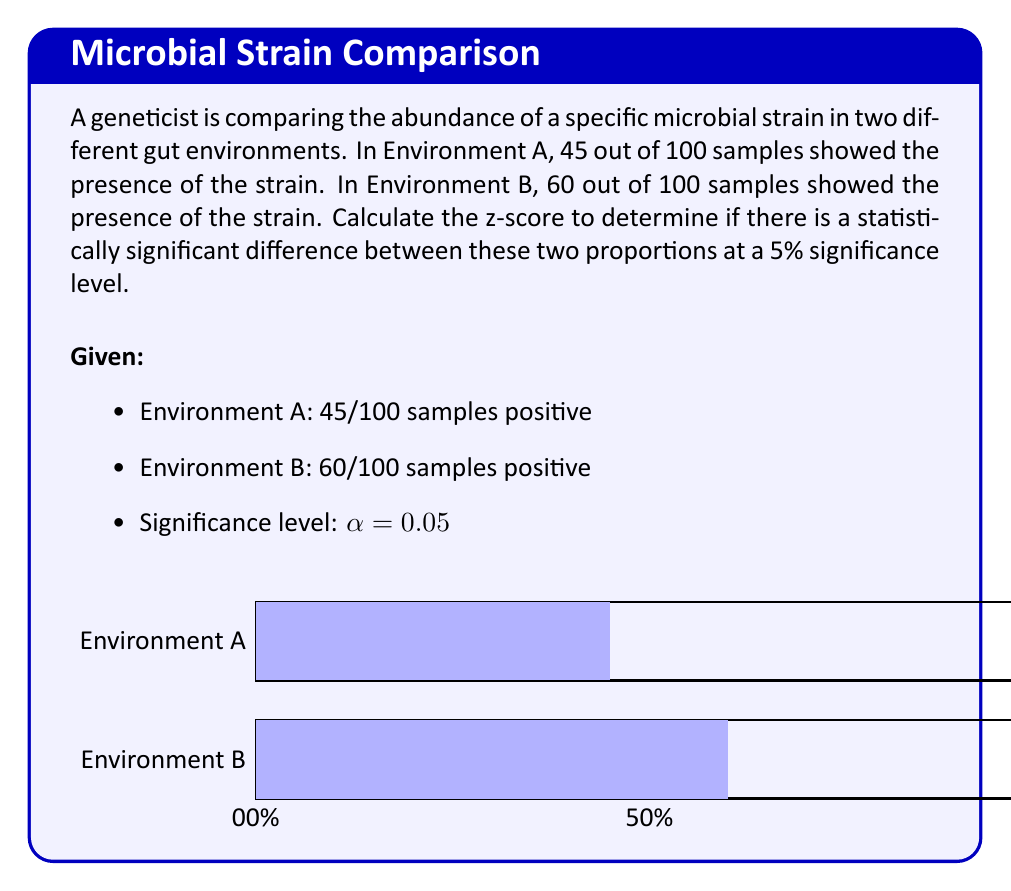Teach me how to tackle this problem. To determine if there is a statistically significant difference between these two proportions, we'll use the z-test for two population proportions. Let's follow these steps:

1) First, we need to calculate the pooled sample proportion:

   $$p = \frac{x_1 + x_2}{n_1 + n_2} = \frac{45 + 60}{100 + 100} = \frac{105}{200} = 0.525$$

2) Now, we can calculate the standard error of the difference between the two proportions:

   $$SE = \sqrt{p(1-p)(\frac{1}{n_1} + \frac{1}{n_2})}$$
   $$SE = \sqrt{0.525(1-0.525)(\frac{1}{100} + \frac{1}{100})}$$
   $$SE = \sqrt{0.24937 \cdot 0.02} = \sqrt{0.0049874} = 0.0706$$

3) Next, we calculate the z-score:

   $$z = \frac{p_1 - p_2}{SE} = \frac{0.45 - 0.60}{0.0706} = -2.12$$

4) For a two-tailed test at a 5% significance level, the critical z-values are ±1.96. Since our calculated z-score (-2.12) falls outside this range, we can conclude that there is a statistically significant difference between the two proportions.

5) To further confirm, we can calculate the p-value:

   p-value = 2 * P(Z < -2.12) ≈ 0.034

   This p-value is less than our significance level of 0.05, confirming our conclusion.
Answer: z-score = -2.12; statistically significant difference (p < 0.05) 